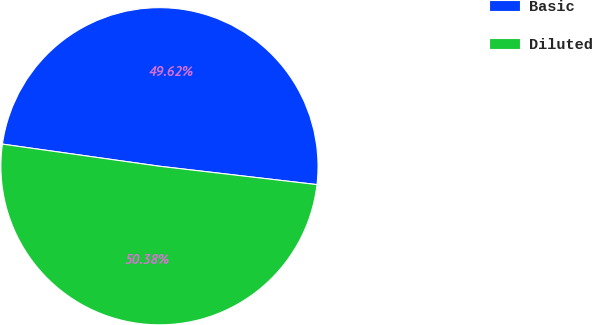<chart> <loc_0><loc_0><loc_500><loc_500><pie_chart><fcel>Basic<fcel>Diluted<nl><fcel>49.62%<fcel>50.38%<nl></chart> 